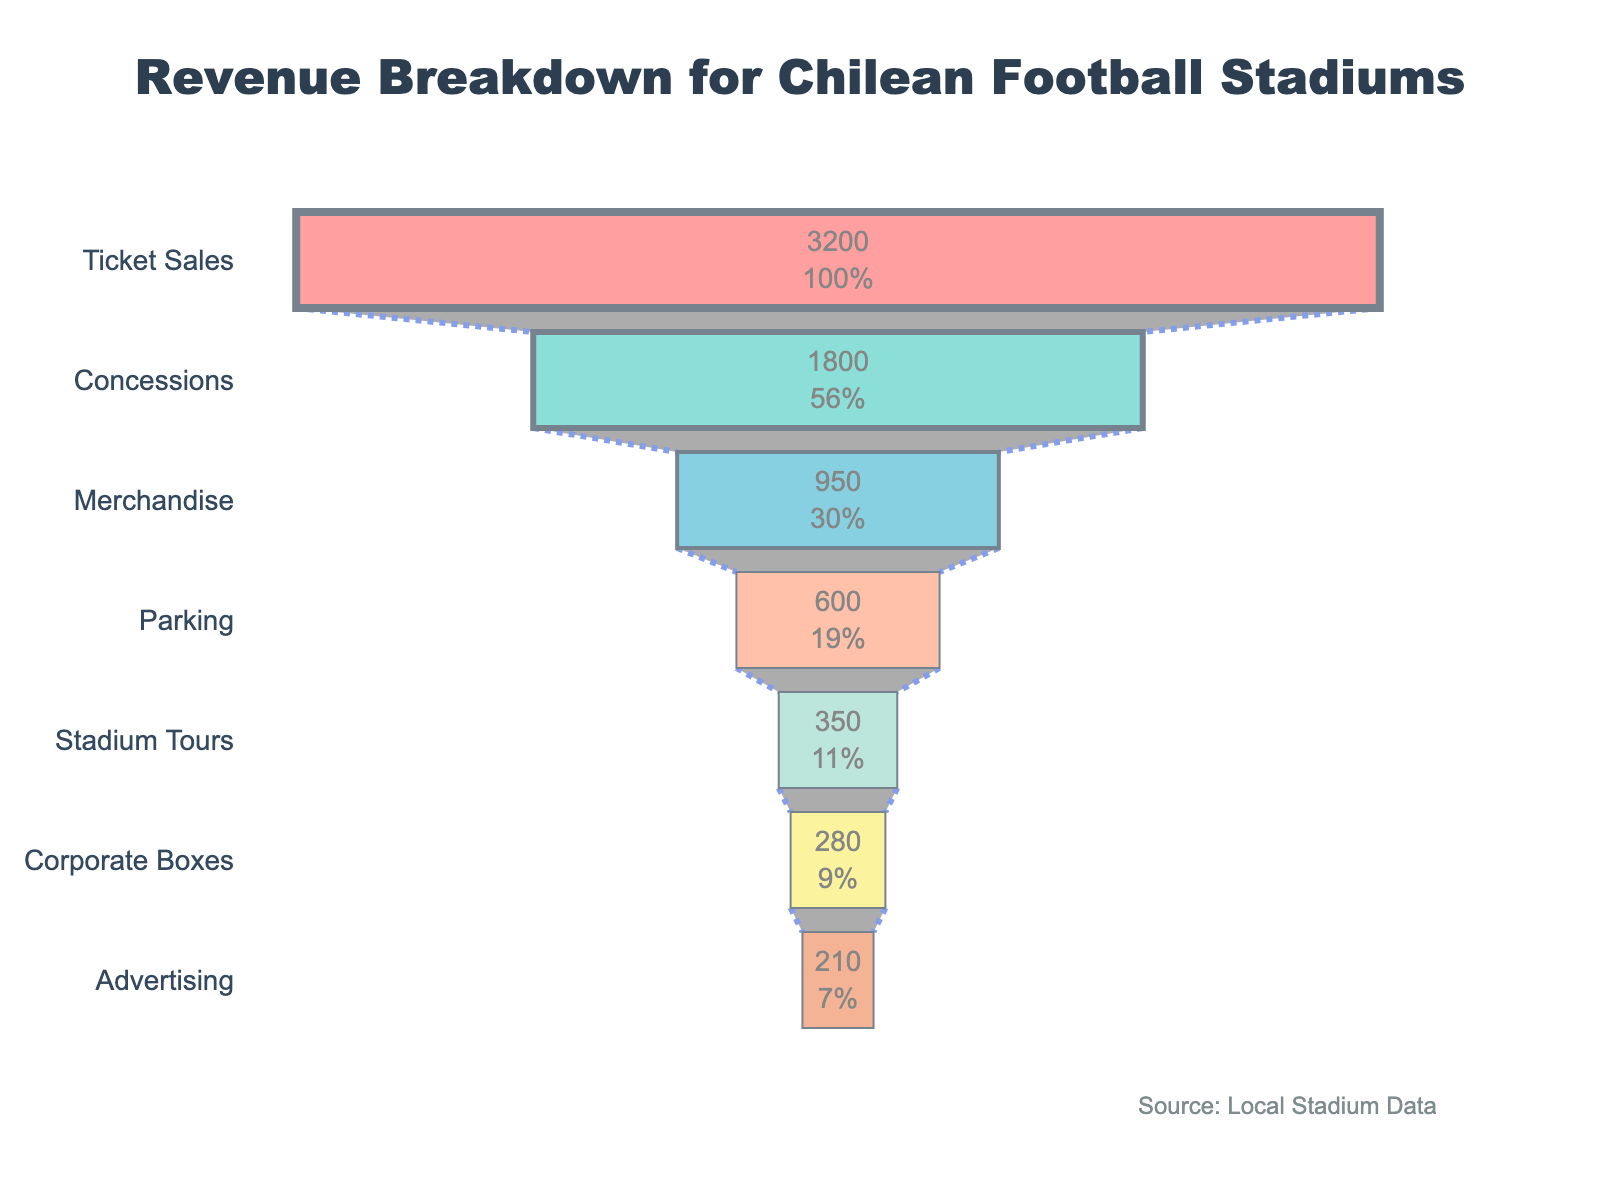What are the top three revenue sources for football stadiums in Chile? The top three revenue sources are the stages with the highest revenue amounts. Based on the funnel chart, these are Ticket Sales, Concessions, and Merchandise.
Answer: Ticket Sales, Concessions, Merchandise What percentage of the total revenue comes from Merchandise? First, sum up all the revenue values: 3200 + 1800 + 950 + 600 + 350 + 280 + 210 = 7390 Million CLP. The percentage from Merchandise is (950/7390) * 100.
Answer: 12.86% How much more revenue do Ticket Sales generate compared to Parking? Subtract the revenue from Parking from the revenue from Ticket Sales: 3200 - 600 = 2600 Million CLP.
Answer: 2600 Million CLP Which revenue source contributes the least to the total revenue? The smallest segment in the funnel chart represents the lowest contributing source, which is Advertising.
Answer: Advertising What is the combined revenue from Corporate Boxes and Advertising? Add the revenue from Corporate Boxes and Advertising: 280 + 210 = 490 Million CLP.
Answer: 490 Million CLP Is the revenue from Concessions more than double the revenue from Merchandise? Double the revenue from Merchandise: 2 * 950 = 1900. Compare it to the revenue from Concessions, which is 1800. Since 1800 is less than 1900, the revenue from Concessions is not more than double.
Answer: No What stage follows Merchandise in terms of revenue contribution? The stage that follows after Merchandise in the funnel chart is Parking.
Answer: Parking What's the percentage drop in revenue from Ticket Sales to Concessions? Calculate the percentage drop: (3200 - 1800) / 3200 * 100 = 43.75%.
Answer: 43.75% How does the revenue from Stadium Tours compare to Corporate Boxes? The revenue from Stadium Tours (350 Million CLP) is higher than that from Corporate Boxes (280 Million CLP).
Answer: Stadium Tours is higher What is the total revenue from all the sources listed in the funnel chart? Sum up all the revenue values from each stage: 3200 + 1800 + 950 + 600 + 350 + 280 + 210 = 7390 Million CLP.
Answer: 7390 Million CLP 